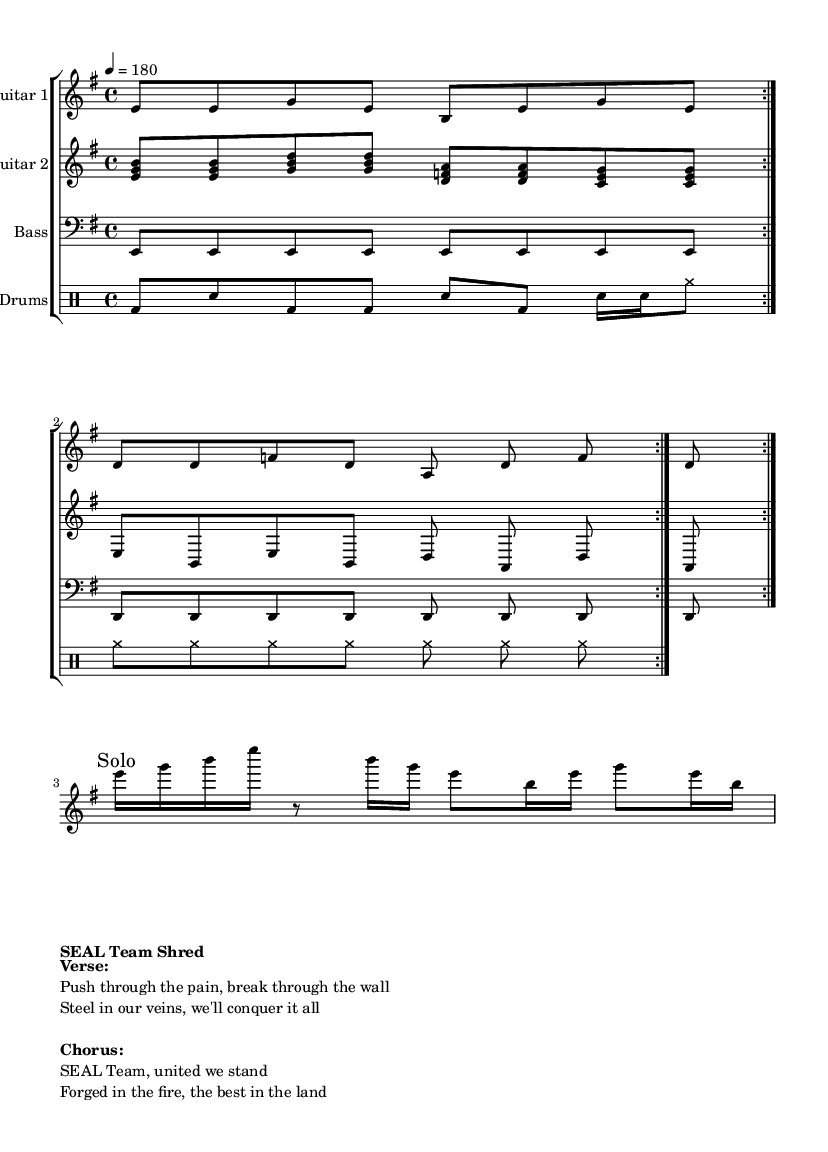What is the key signature of this music? The key signature is indicated at the beginning of the staff. In this case, there is one sharp (F sharp), meaning the key is E minor.
Answer: E minor What is the time signature of this music? The time signature is shown at the beginning of the sheet music, where it reads "4/4". This means there are four beats per measure.
Answer: 4/4 What is the tempo marking for this piece? The tempo marking is found at the beginning where it reads "4 = 180", indicating that's the beats per minute, which is a fast tempo.
Answer: 180 How many times is the first musical phrase repeated? The first musical phrase is noted with a "repeat volta 2", meaning it is played twice before moving on.
Answer: 2 What is the instrument primarily featured in the melody? The first staff is labeled "Electric Guitar 1", which indicates it carries the main melody throughout the piece.
Answer: Electric Guitar 1 In what section does the solo occur? The solo is marked distinctly in the sheet music; it says "Solo" within the melody, indicating its specific section.
Answer: Solo What is the main theme of the chorus? The lyrics of the chorus are provided in the markup, which outlines the key message of unity and strength of the SEAL team.
Answer: United we stand 